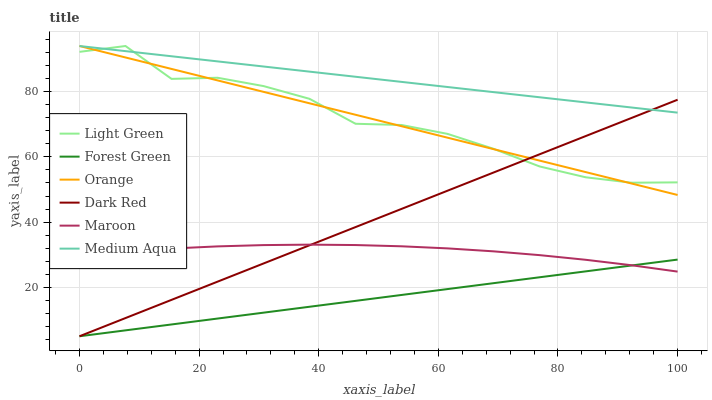Does Forest Green have the minimum area under the curve?
Answer yes or no. Yes. Does Medium Aqua have the maximum area under the curve?
Answer yes or no. Yes. Does Maroon have the minimum area under the curve?
Answer yes or no. No. Does Maroon have the maximum area under the curve?
Answer yes or no. No. Is Forest Green the smoothest?
Answer yes or no. Yes. Is Light Green the roughest?
Answer yes or no. Yes. Is Maroon the smoothest?
Answer yes or no. No. Is Maroon the roughest?
Answer yes or no. No. Does Maroon have the lowest value?
Answer yes or no. No. Does Maroon have the highest value?
Answer yes or no. No. Is Maroon less than Medium Aqua?
Answer yes or no. Yes. Is Orange greater than Forest Green?
Answer yes or no. Yes. Does Maroon intersect Medium Aqua?
Answer yes or no. No. 